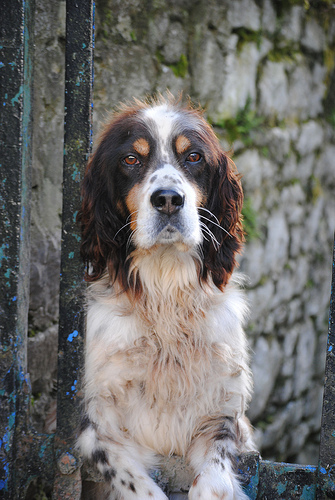<image>
Is the dog under the wall? No. The dog is not positioned under the wall. The vertical relationship between these objects is different. Where is the dog in relation to the wall? Is it behind the wall? No. The dog is not behind the wall. From this viewpoint, the dog appears to be positioned elsewhere in the scene. Is the dog to the right of the wall? No. The dog is not to the right of the wall. The horizontal positioning shows a different relationship. 